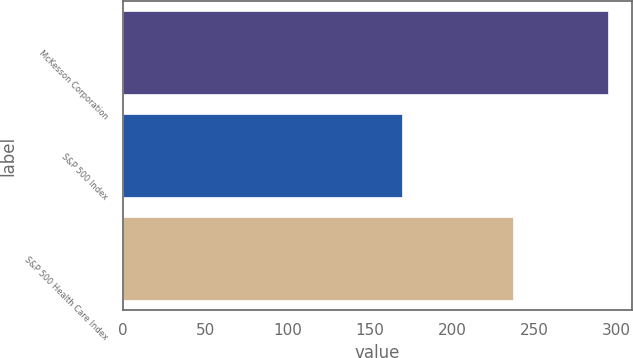Convert chart. <chart><loc_0><loc_0><loc_500><loc_500><bar_chart><fcel>McKesson Corporation<fcel>S&P 500 Index<fcel>S&P 500 Health Care Index<nl><fcel>294.79<fcel>169.92<fcel>237.45<nl></chart> 